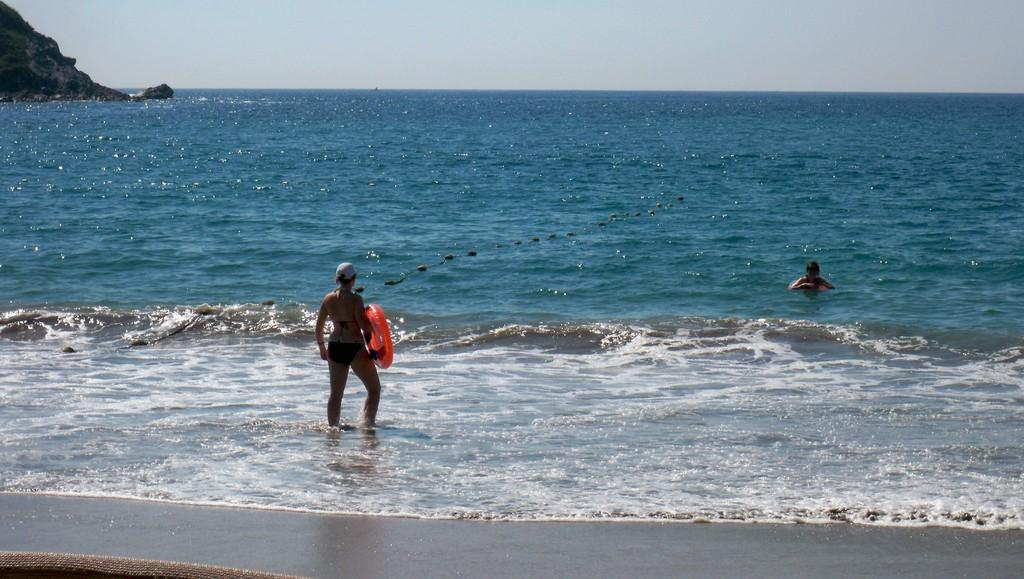What is the woman in the image holding? The woman is holding an object in the image. Where is the woman standing in the image? The woman is standing in water in the image. Can you describe the other person in the image? There is another person in the water in front of the woman. What can be seen in the background of the image? There is a mountain visible in the left top corner of the image. What type of jelly is the woman using to surprise the person in front of her? There is no jelly present in the image, and the woman is not attempting to surprise the person in front of her. 